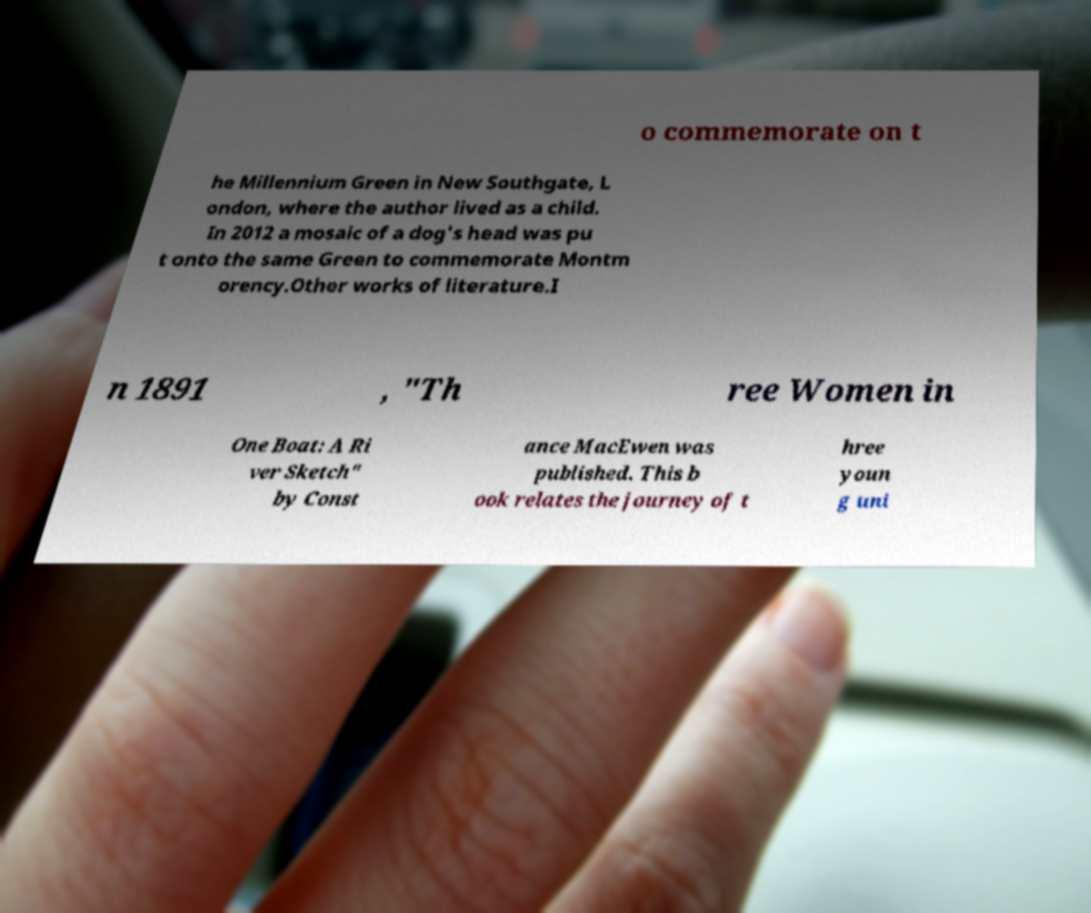What messages or text are displayed in this image? I need them in a readable, typed format. o commemorate on t he Millennium Green in New Southgate, L ondon, where the author lived as a child. In 2012 a mosaic of a dog's head was pu t onto the same Green to commemorate Montm orency.Other works of literature.I n 1891 , "Th ree Women in One Boat: A Ri ver Sketch" by Const ance MacEwen was published. This b ook relates the journey of t hree youn g uni 